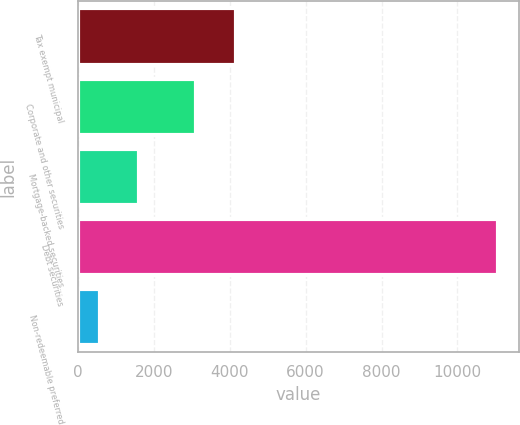Convert chart. <chart><loc_0><loc_0><loc_500><loc_500><bar_chart><fcel>Tax exempt municipal<fcel>Corporate and other securities<fcel>Mortgage-backed securities<fcel>Debt securities<fcel>Non-redeemable preferred<nl><fcel>4171.6<fcel>3121<fcel>1619.6<fcel>11075<fcel>569<nl></chart> 